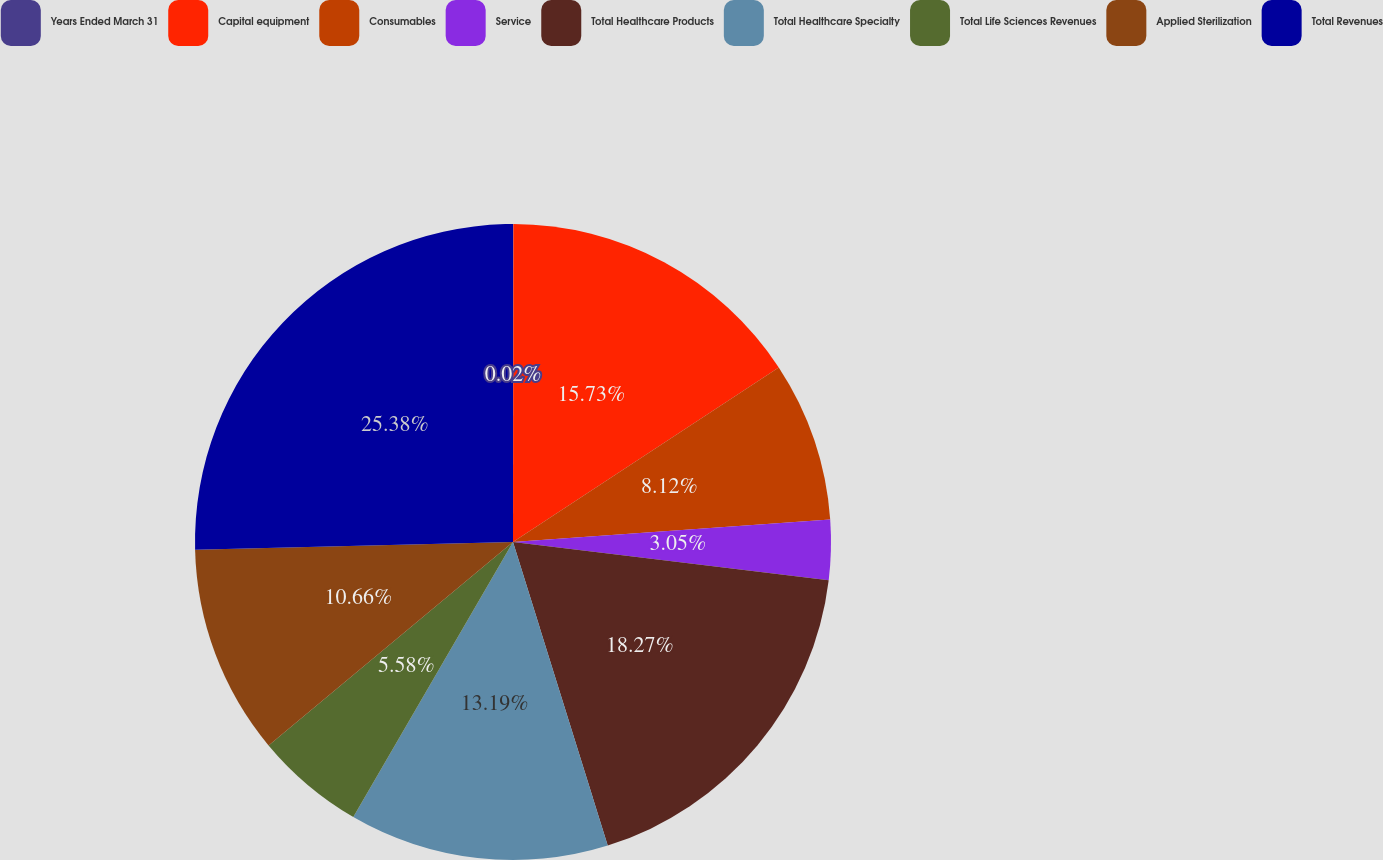Convert chart. <chart><loc_0><loc_0><loc_500><loc_500><pie_chart><fcel>Years Ended March 31<fcel>Capital equipment<fcel>Consumables<fcel>Service<fcel>Total Healthcare Products<fcel>Total Healthcare Specialty<fcel>Total Life Sciences Revenues<fcel>Applied Sterilization<fcel>Total Revenues<nl><fcel>0.02%<fcel>15.73%<fcel>8.12%<fcel>3.05%<fcel>18.27%<fcel>13.19%<fcel>5.58%<fcel>10.66%<fcel>25.39%<nl></chart> 